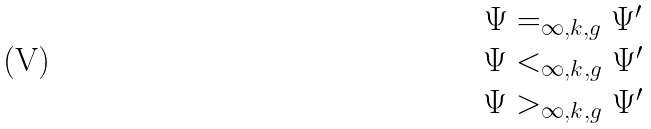Convert formula to latex. <formula><loc_0><loc_0><loc_500><loc_500>\begin{array} { c } \Psi = _ { \infty , k , g } \Psi ^ { \prime } \\ \Psi < _ { \infty , k , g } \Psi ^ { \prime } \\ \Psi > _ { \infty , k , g } \Psi ^ { \prime } \end{array}</formula> 